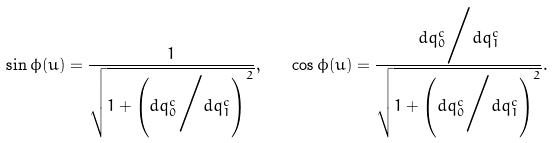Convert formula to latex. <formula><loc_0><loc_0><loc_500><loc_500>\sin \phi ( u ) = \frac { 1 } { \sqrt { 1 + \left ( { d q _ { 0 } ^ { c } } \Big / { d q _ { 1 } ^ { c } } \right ) ^ { 2 } } } , \quad \cos \phi ( u ) = \frac { { d q _ { 0 } ^ { c } } \Big / { d q _ { 1 } ^ { c } } } { \sqrt { 1 + \left ( { d q _ { 0 } ^ { c } } \Big / { d q _ { 1 } ^ { c } } \right ) ^ { 2 } } } .</formula> 